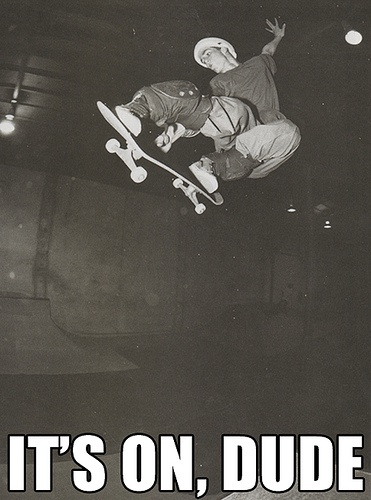Describe the objects in this image and their specific colors. I can see people in black, gray, darkgray, and lightgray tones, skateboard in black, lightgray, and gray tones, and people in black, gray, darkgray, and lightgray tones in this image. 